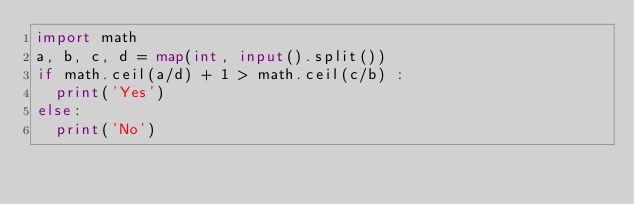Convert code to text. <code><loc_0><loc_0><loc_500><loc_500><_Python_>import math
a, b, c, d = map(int, input().split())
if math.ceil(a/d) + 1 > math.ceil(c/b) :
  print('Yes')
else:
  print('No')
</code> 